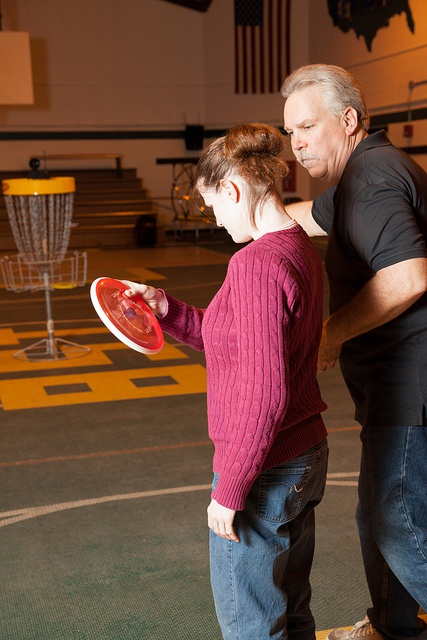Describe the objects in this image and their specific colors. I can see people in maroon, black, salmon, and brown tones, people in maroon, black, gray, and tan tones, and frisbee in maroon, brown, red, salmon, and white tones in this image. 